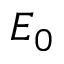<formula> <loc_0><loc_0><loc_500><loc_500>E _ { 0 }</formula> 